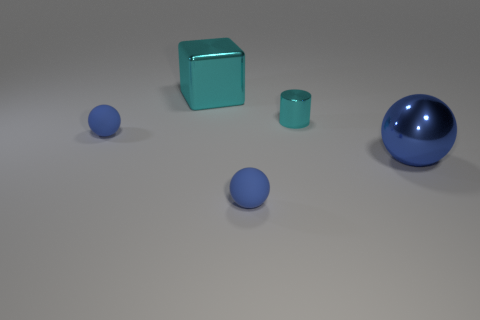Subtract all blue spheres. How many were subtracted if there are1blue spheres left? 2 Add 3 small shiny cubes. How many objects exist? 8 Subtract all spheres. How many objects are left? 2 Add 1 tiny cyan things. How many tiny cyan things are left? 2 Add 1 blue metallic balls. How many blue metallic balls exist? 2 Subtract 0 red balls. How many objects are left? 5 Subtract all blue shiny spheres. Subtract all cyan metal objects. How many objects are left? 2 